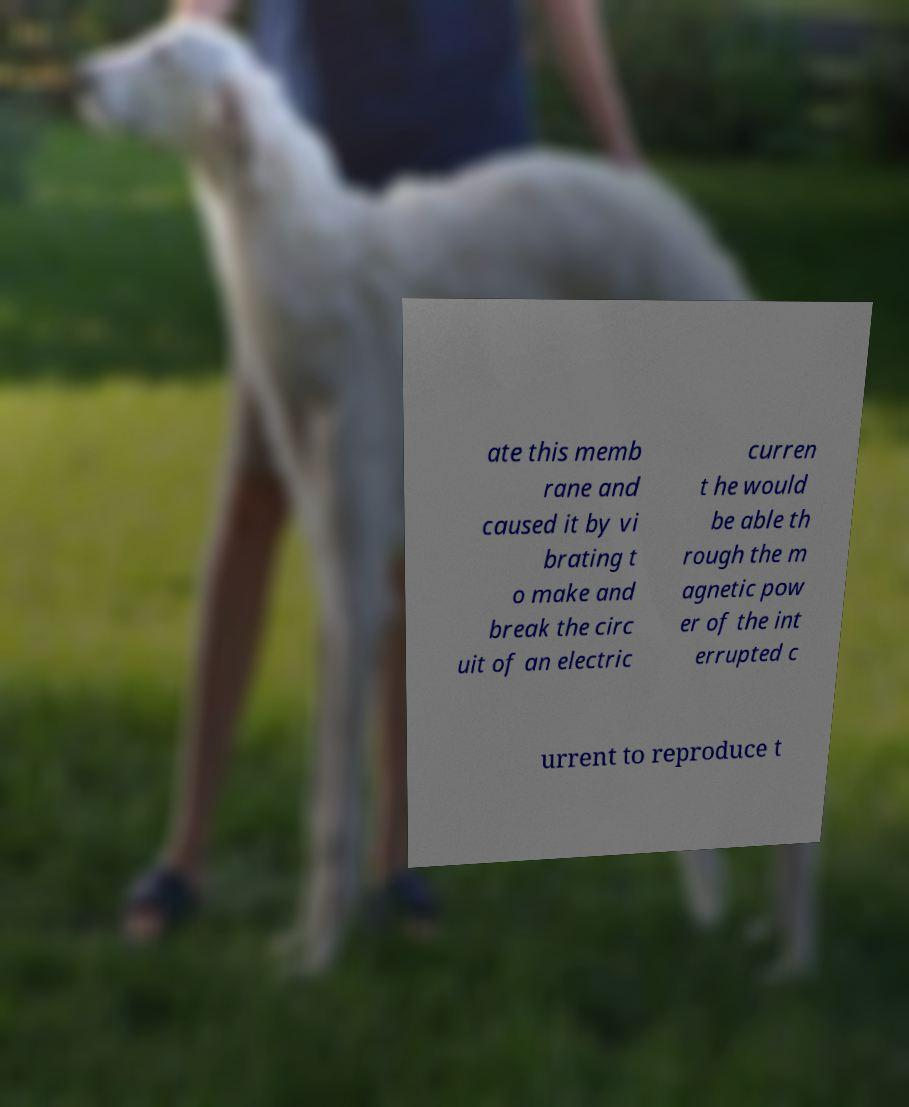I need the written content from this picture converted into text. Can you do that? ate this memb rane and caused it by vi brating t o make and break the circ uit of an electric curren t he would be able th rough the m agnetic pow er of the int errupted c urrent to reproduce t 